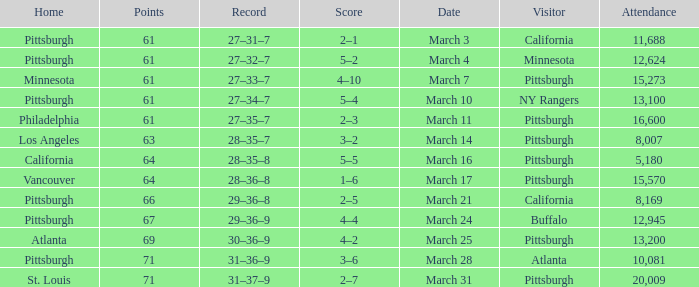Could you help me parse every detail presented in this table? {'header': ['Home', 'Points', 'Record', 'Score', 'Date', 'Visitor', 'Attendance'], 'rows': [['Pittsburgh', '61', '27–31–7', '2–1', 'March 3', 'California', '11,688'], ['Pittsburgh', '61', '27–32–7', '5–2', 'March 4', 'Minnesota', '12,624'], ['Minnesota', '61', '27–33–7', '4–10', 'March 7', 'Pittsburgh', '15,273'], ['Pittsburgh', '61', '27–34–7', '5–4', 'March 10', 'NY Rangers', '13,100'], ['Philadelphia', '61', '27–35–7', '2–3', 'March 11', 'Pittsburgh', '16,600'], ['Los Angeles', '63', '28–35–7', '3–2', 'March 14', 'Pittsburgh', '8,007'], ['California', '64', '28–35–8', '5–5', 'March 16', 'Pittsburgh', '5,180'], ['Vancouver', '64', '28–36–8', '1–6', 'March 17', 'Pittsburgh', '15,570'], ['Pittsburgh', '66', '29–36–8', '2–5', 'March 21', 'California', '8,169'], ['Pittsburgh', '67', '29–36–9', '4–4', 'March 24', 'Buffalo', '12,945'], ['Atlanta', '69', '30–36–9', '4–2', 'March 25', 'Pittsburgh', '13,200'], ['Pittsburgh', '71', '31–36–9', '3–6', 'March 28', 'Atlanta', '10,081'], ['St. Louis', '71', '31–37–9', '2–7', 'March 31', 'Pittsburgh', '20,009']]} What is the Score of the Pittsburgh Home game on March 3 with 61 Points? 2–1. 